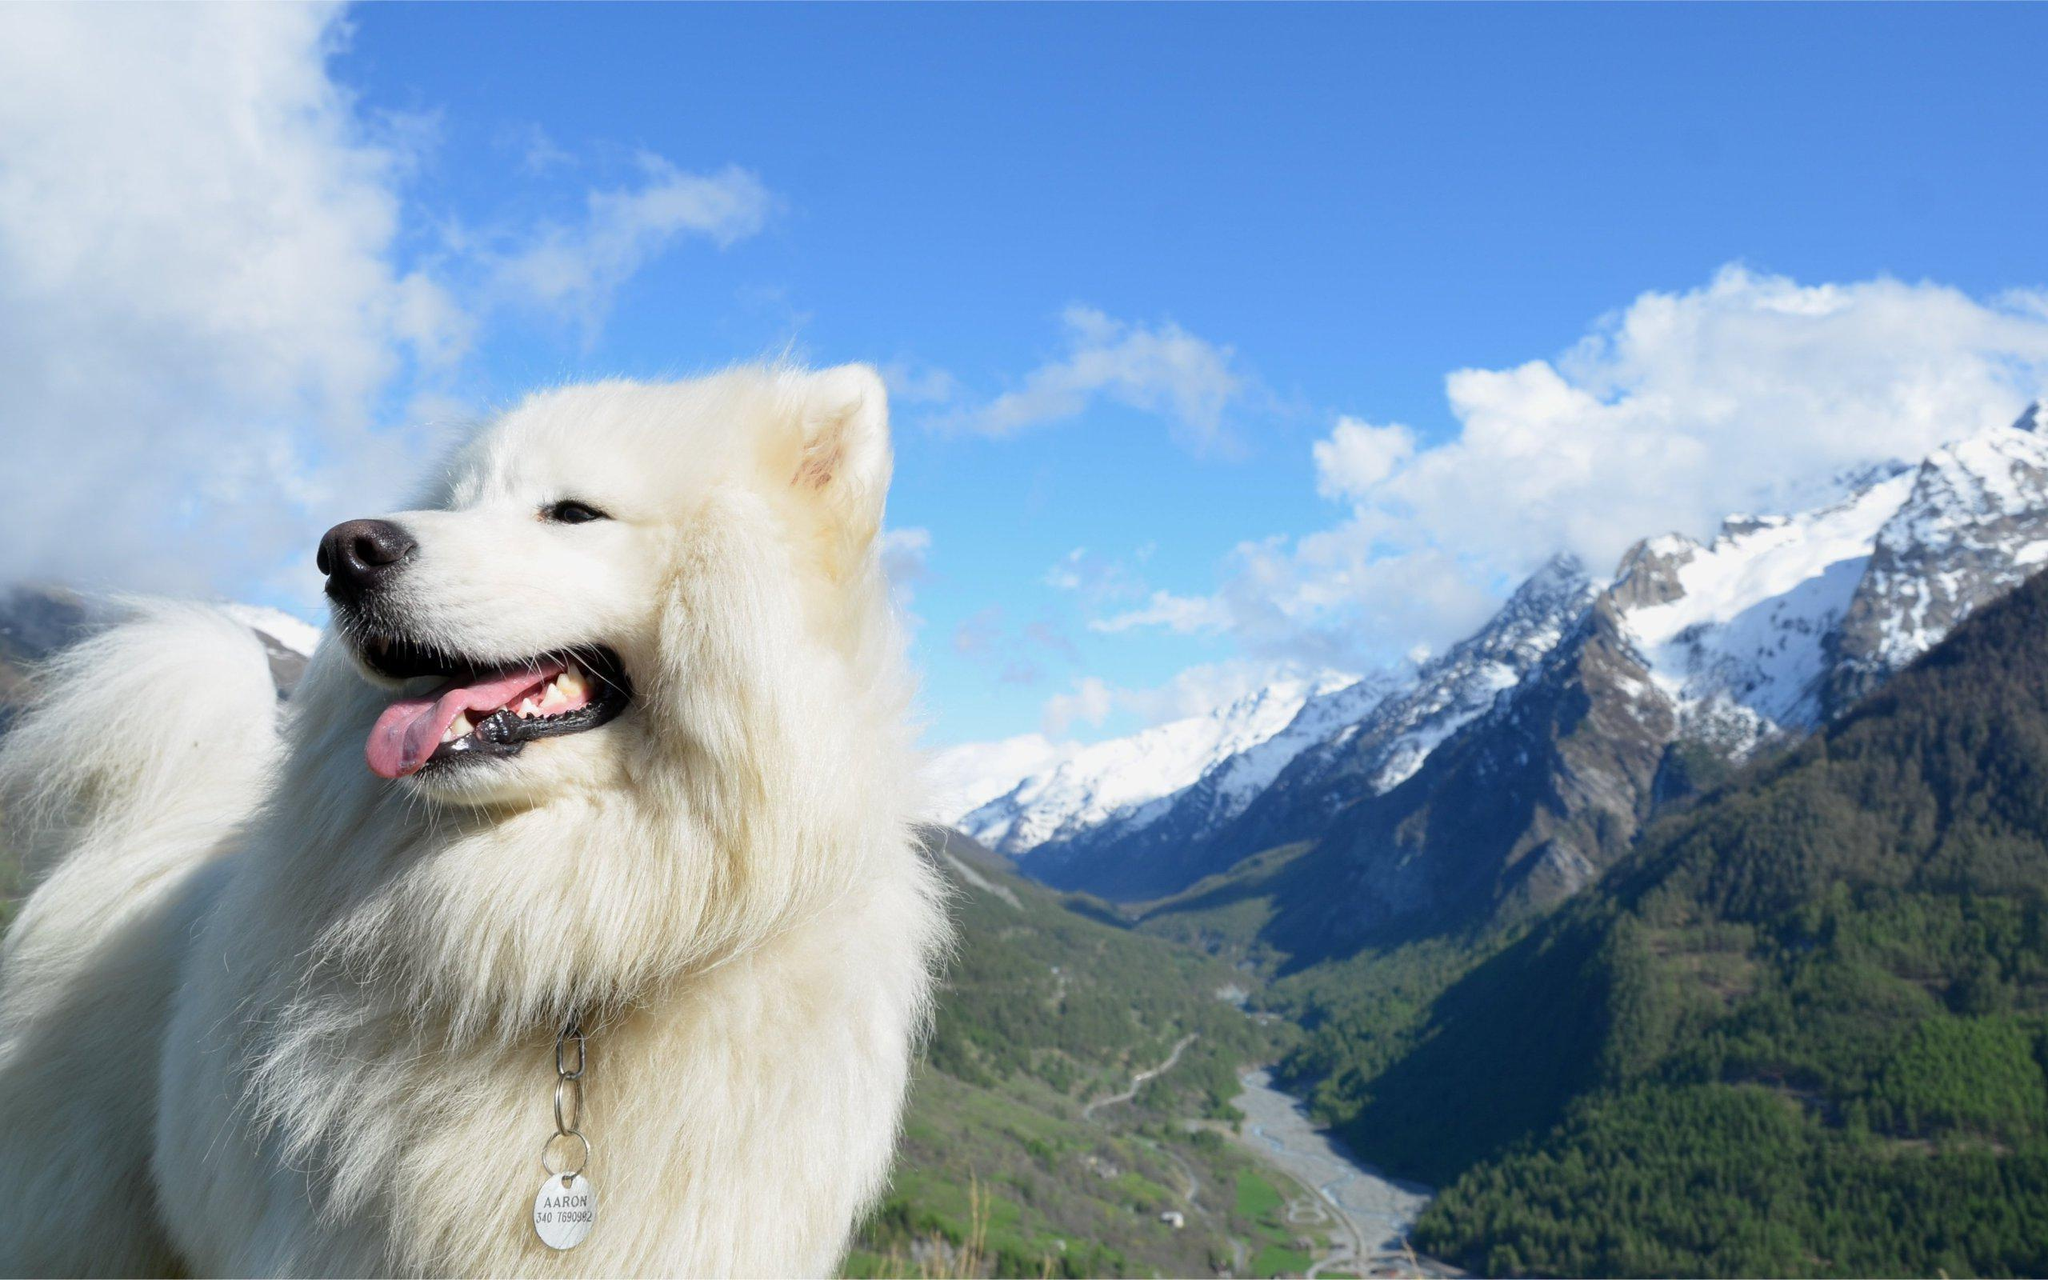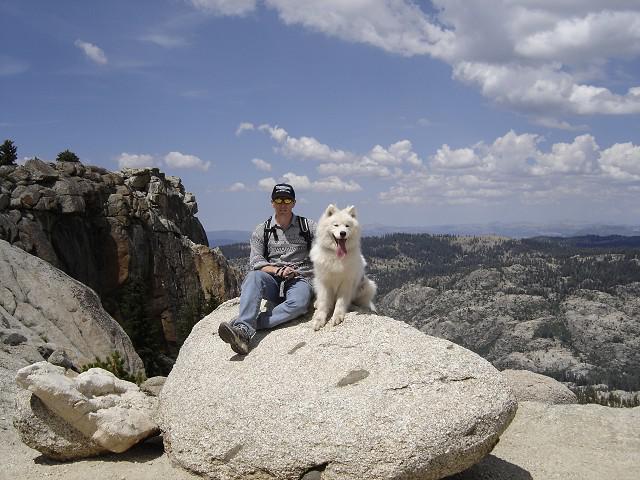The first image is the image on the left, the second image is the image on the right. Given the left and right images, does the statement "Two white dogs wearing matching packs are side-by-side on an overlook, with hilly scenery in the background." hold true? Answer yes or no. No. The first image is the image on the left, the second image is the image on the right. For the images displayed, is the sentence "There are three dogs in the image pair." factually correct? Answer yes or no. No. 